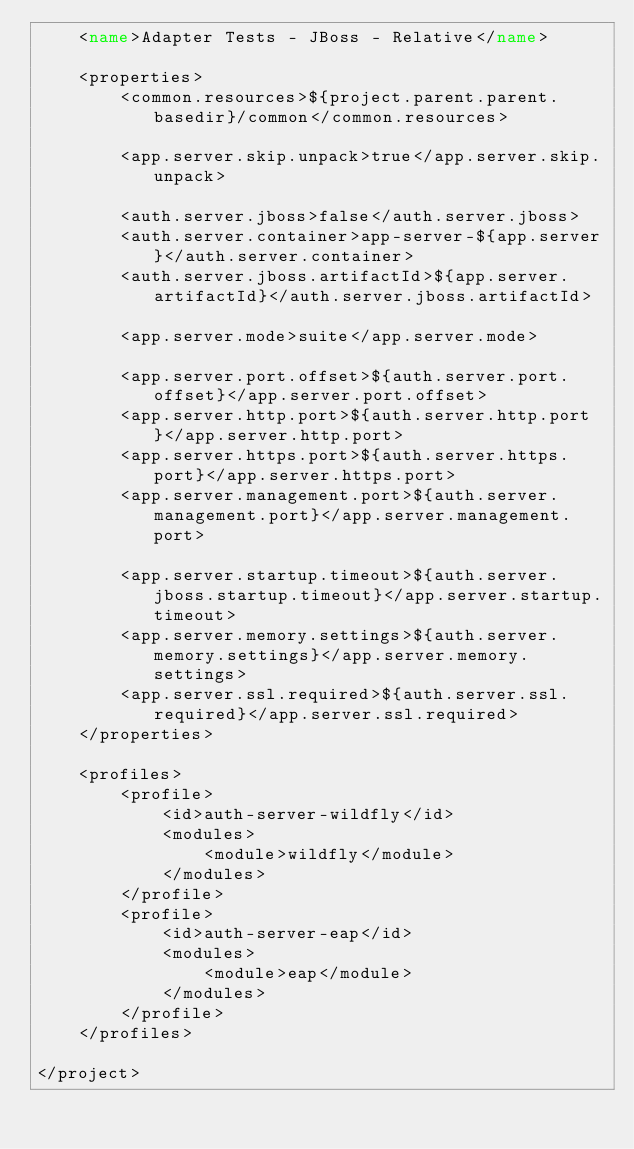Convert code to text. <code><loc_0><loc_0><loc_500><loc_500><_XML_>    <name>Adapter Tests - JBoss - Relative</name>
    
    <properties>
        <common.resources>${project.parent.parent.basedir}/common</common.resources>
        
        <app.server.skip.unpack>true</app.server.skip.unpack>
        
        <auth.server.jboss>false</auth.server.jboss>
        <auth.server.container>app-server-${app.server}</auth.server.container>
        <auth.server.jboss.artifactId>${app.server.artifactId}</auth.server.jboss.artifactId>
        
        <app.server.mode>suite</app.server.mode>
        
        <app.server.port.offset>${auth.server.port.offset}</app.server.port.offset>
        <app.server.http.port>${auth.server.http.port}</app.server.http.port>
        <app.server.https.port>${auth.server.https.port}</app.server.https.port>
        <app.server.management.port>${auth.server.management.port}</app.server.management.port>

        <app.server.startup.timeout>${auth.server.jboss.startup.timeout}</app.server.startup.timeout>
        <app.server.memory.settings>${auth.server.memory.settings}</app.server.memory.settings>
        <app.server.ssl.required>${auth.server.ssl.required}</app.server.ssl.required>        
    </properties>
    
    <profiles>
        <profile>
            <id>auth-server-wildfly</id>
            <modules>
                <module>wildfly</module>
            </modules>
        </profile>
        <profile>
            <id>auth-server-eap</id>
            <modules>
                <module>eap</module>
            </modules>
        </profile>
    </profiles>
        
</project></code> 